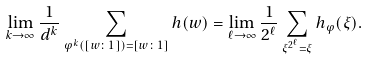Convert formula to latex. <formula><loc_0><loc_0><loc_500><loc_500>\lim _ { { k } \to \infty } \frac { 1 } { d ^ { k } } \sum _ { \varphi ^ { k } ( [ w \colon 1 ] ) = [ w \colon 1 ] } h ( w ) = \lim _ { { \ell } \to \infty } \frac { 1 } { 2 ^ { \ell } } \sum _ { \xi ^ { { 2 } ^ { \ell } } = \xi } h _ { \varphi } ( \xi ) .</formula> 